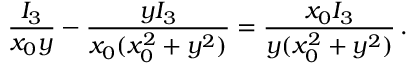Convert formula to latex. <formula><loc_0><loc_0><loc_500><loc_500>\frac { I _ { 3 } } { x _ { 0 } y } - \frac { y I _ { 3 } } { x _ { 0 } ( x _ { 0 } ^ { 2 } + y ^ { 2 } ) } = \frac { x _ { 0 } I _ { 3 } } { y ( x _ { 0 } ^ { 2 } + y ^ { 2 } ) } \, .</formula> 